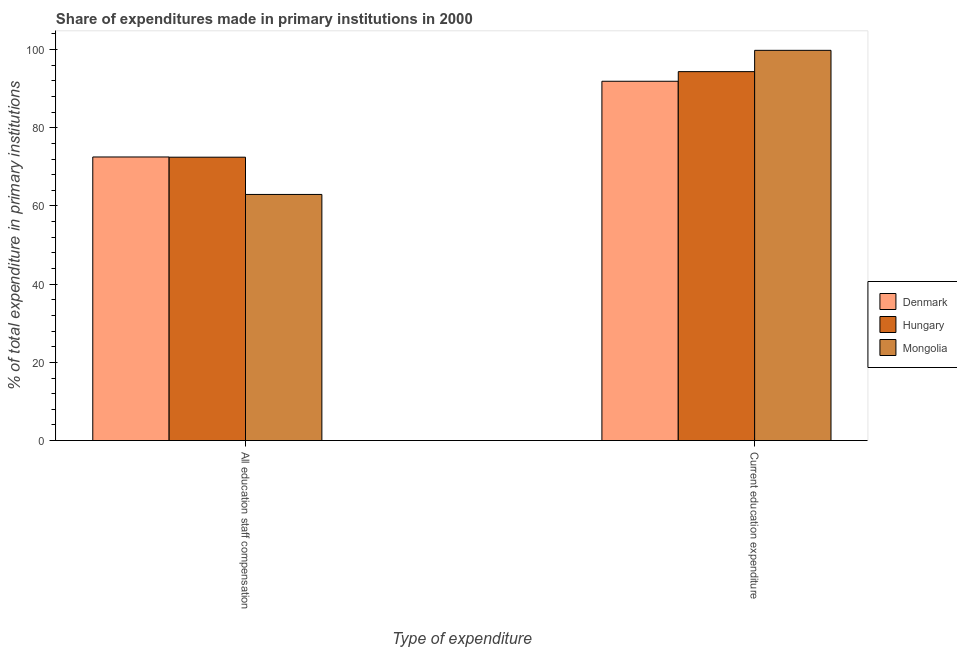Are the number of bars per tick equal to the number of legend labels?
Offer a very short reply. Yes. How many bars are there on the 2nd tick from the left?
Offer a terse response. 3. How many bars are there on the 2nd tick from the right?
Give a very brief answer. 3. What is the label of the 2nd group of bars from the left?
Make the answer very short. Current education expenditure. What is the expenditure in education in Mongolia?
Your answer should be very brief. 99.8. Across all countries, what is the maximum expenditure in education?
Give a very brief answer. 99.8. Across all countries, what is the minimum expenditure in education?
Keep it short and to the point. 91.89. What is the total expenditure in education in the graph?
Make the answer very short. 286.05. What is the difference between the expenditure in staff compensation in Denmark and that in Hungary?
Provide a succinct answer. 0.06. What is the difference between the expenditure in education in Mongolia and the expenditure in staff compensation in Hungary?
Provide a succinct answer. 27.33. What is the average expenditure in staff compensation per country?
Keep it short and to the point. 69.31. What is the difference between the expenditure in staff compensation and expenditure in education in Denmark?
Provide a short and direct response. -19.37. What is the ratio of the expenditure in education in Hungary to that in Mongolia?
Provide a succinct answer. 0.95. Is the expenditure in education in Denmark less than that in Mongolia?
Ensure brevity in your answer.  Yes. What does the 1st bar from the left in All education staff compensation represents?
Give a very brief answer. Denmark. What does the 2nd bar from the right in Current education expenditure represents?
Provide a short and direct response. Hungary. Are all the bars in the graph horizontal?
Ensure brevity in your answer.  No. How many countries are there in the graph?
Ensure brevity in your answer.  3. Are the values on the major ticks of Y-axis written in scientific E-notation?
Offer a terse response. No. Does the graph contain any zero values?
Provide a short and direct response. No. Where does the legend appear in the graph?
Keep it short and to the point. Center right. What is the title of the graph?
Your answer should be compact. Share of expenditures made in primary institutions in 2000. Does "Morocco" appear as one of the legend labels in the graph?
Make the answer very short. No. What is the label or title of the X-axis?
Offer a terse response. Type of expenditure. What is the label or title of the Y-axis?
Your response must be concise. % of total expenditure in primary institutions. What is the % of total expenditure in primary institutions in Denmark in All education staff compensation?
Provide a succinct answer. 72.53. What is the % of total expenditure in primary institutions in Hungary in All education staff compensation?
Make the answer very short. 72.47. What is the % of total expenditure in primary institutions in Mongolia in All education staff compensation?
Keep it short and to the point. 62.94. What is the % of total expenditure in primary institutions in Denmark in Current education expenditure?
Ensure brevity in your answer.  91.89. What is the % of total expenditure in primary institutions in Hungary in Current education expenditure?
Offer a terse response. 94.35. What is the % of total expenditure in primary institutions in Mongolia in Current education expenditure?
Your answer should be compact. 99.8. Across all Type of expenditure, what is the maximum % of total expenditure in primary institutions of Denmark?
Your response must be concise. 91.89. Across all Type of expenditure, what is the maximum % of total expenditure in primary institutions in Hungary?
Give a very brief answer. 94.35. Across all Type of expenditure, what is the maximum % of total expenditure in primary institutions of Mongolia?
Make the answer very short. 99.8. Across all Type of expenditure, what is the minimum % of total expenditure in primary institutions of Denmark?
Keep it short and to the point. 72.53. Across all Type of expenditure, what is the minimum % of total expenditure in primary institutions in Hungary?
Make the answer very short. 72.47. Across all Type of expenditure, what is the minimum % of total expenditure in primary institutions of Mongolia?
Offer a terse response. 62.94. What is the total % of total expenditure in primary institutions in Denmark in the graph?
Your answer should be very brief. 164.42. What is the total % of total expenditure in primary institutions of Hungary in the graph?
Provide a short and direct response. 166.82. What is the total % of total expenditure in primary institutions in Mongolia in the graph?
Provide a succinct answer. 162.74. What is the difference between the % of total expenditure in primary institutions in Denmark in All education staff compensation and that in Current education expenditure?
Provide a succinct answer. -19.37. What is the difference between the % of total expenditure in primary institutions of Hungary in All education staff compensation and that in Current education expenditure?
Keep it short and to the point. -21.88. What is the difference between the % of total expenditure in primary institutions of Mongolia in All education staff compensation and that in Current education expenditure?
Provide a short and direct response. -36.86. What is the difference between the % of total expenditure in primary institutions in Denmark in All education staff compensation and the % of total expenditure in primary institutions in Hungary in Current education expenditure?
Ensure brevity in your answer.  -21.83. What is the difference between the % of total expenditure in primary institutions of Denmark in All education staff compensation and the % of total expenditure in primary institutions of Mongolia in Current education expenditure?
Provide a short and direct response. -27.27. What is the difference between the % of total expenditure in primary institutions of Hungary in All education staff compensation and the % of total expenditure in primary institutions of Mongolia in Current education expenditure?
Offer a terse response. -27.33. What is the average % of total expenditure in primary institutions of Denmark per Type of expenditure?
Offer a very short reply. 82.21. What is the average % of total expenditure in primary institutions in Hungary per Type of expenditure?
Your answer should be very brief. 83.41. What is the average % of total expenditure in primary institutions in Mongolia per Type of expenditure?
Keep it short and to the point. 81.37. What is the difference between the % of total expenditure in primary institutions in Denmark and % of total expenditure in primary institutions in Hungary in All education staff compensation?
Your answer should be very brief. 0.06. What is the difference between the % of total expenditure in primary institutions in Denmark and % of total expenditure in primary institutions in Mongolia in All education staff compensation?
Provide a short and direct response. 9.58. What is the difference between the % of total expenditure in primary institutions in Hungary and % of total expenditure in primary institutions in Mongolia in All education staff compensation?
Offer a terse response. 9.53. What is the difference between the % of total expenditure in primary institutions in Denmark and % of total expenditure in primary institutions in Hungary in Current education expenditure?
Make the answer very short. -2.46. What is the difference between the % of total expenditure in primary institutions in Denmark and % of total expenditure in primary institutions in Mongolia in Current education expenditure?
Make the answer very short. -7.91. What is the difference between the % of total expenditure in primary institutions of Hungary and % of total expenditure in primary institutions of Mongolia in Current education expenditure?
Provide a short and direct response. -5.45. What is the ratio of the % of total expenditure in primary institutions in Denmark in All education staff compensation to that in Current education expenditure?
Provide a succinct answer. 0.79. What is the ratio of the % of total expenditure in primary institutions of Hungary in All education staff compensation to that in Current education expenditure?
Keep it short and to the point. 0.77. What is the ratio of the % of total expenditure in primary institutions of Mongolia in All education staff compensation to that in Current education expenditure?
Ensure brevity in your answer.  0.63. What is the difference between the highest and the second highest % of total expenditure in primary institutions in Denmark?
Your response must be concise. 19.37. What is the difference between the highest and the second highest % of total expenditure in primary institutions in Hungary?
Offer a very short reply. 21.88. What is the difference between the highest and the second highest % of total expenditure in primary institutions in Mongolia?
Offer a terse response. 36.86. What is the difference between the highest and the lowest % of total expenditure in primary institutions in Denmark?
Your answer should be very brief. 19.37. What is the difference between the highest and the lowest % of total expenditure in primary institutions in Hungary?
Provide a succinct answer. 21.88. What is the difference between the highest and the lowest % of total expenditure in primary institutions in Mongolia?
Your response must be concise. 36.86. 